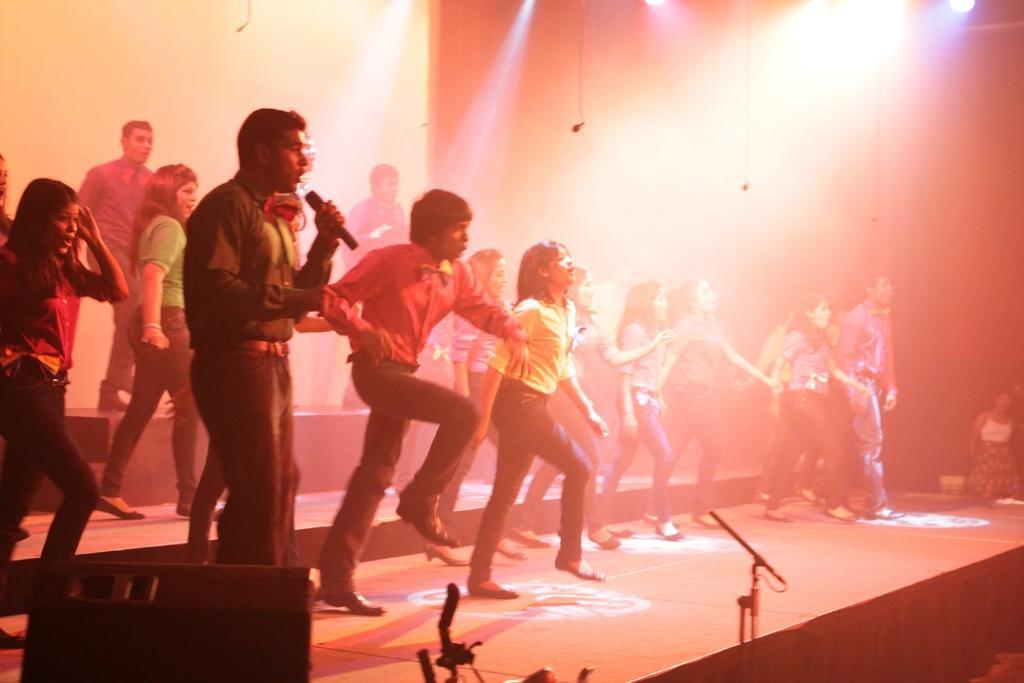In one or two sentences, can you explain what this image depicts? In this image we can see group of persons dancing on the floor. At the bottom of the image we can see speaker and mic stand. In the background there are lights, screen and wall. 